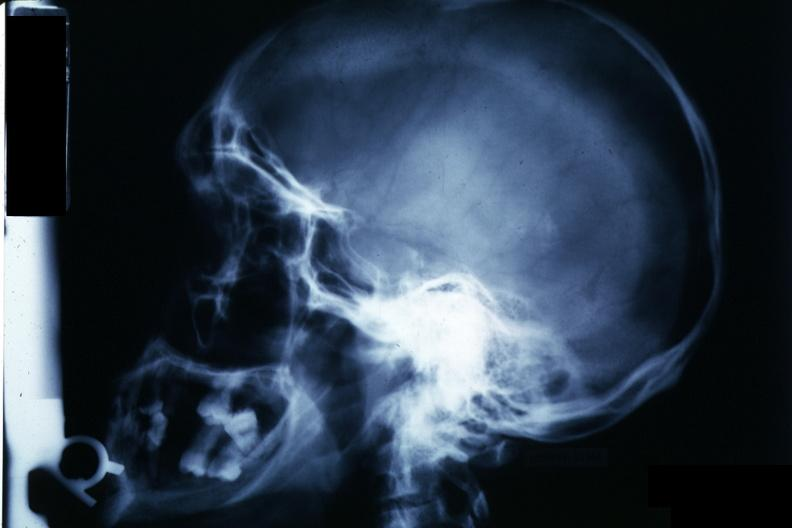s pus in test tube present?
Answer the question using a single word or phrase. No 